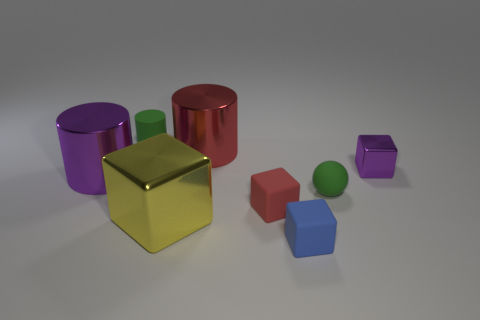What is the size of the red matte thing that is the same shape as the blue object?
Your answer should be compact. Small. There is a ball; does it have the same color as the cube that is on the right side of the blue matte cube?
Your response must be concise. No. What number of other objects are there of the same size as the yellow cube?
Your answer should be compact. 2. The object that is to the left of the green rubber object that is behind the cylinder that is to the right of the yellow object is what shape?
Offer a terse response. Cylinder. Does the ball have the same size as the purple metallic thing that is to the left of the tiny blue rubber cube?
Your answer should be compact. No. There is a large metallic thing that is behind the big yellow metallic block and in front of the red cylinder; what color is it?
Your answer should be very brief. Purple. What number of other objects are the same shape as the red shiny thing?
Your answer should be compact. 2. There is a big cylinder in front of the large red cylinder; is it the same color as the cylinder on the right side of the small matte cylinder?
Give a very brief answer. No. Do the rubber object that is in front of the big yellow cube and the purple metal cylinder behind the blue cube have the same size?
Offer a very short reply. No. Are there any other things that are the same material as the big yellow thing?
Make the answer very short. Yes. 